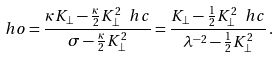Convert formula to latex. <formula><loc_0><loc_0><loc_500><loc_500>\ h o = \frac { \kappa K _ { \perp } - \frac { \kappa } { 2 } K _ { \perp } ^ { 2 } \ h c } { \sigma - \frac { \kappa } { 2 } K _ { \perp } ^ { 2 } } = \frac { K _ { \perp } - \frac { 1 } { 2 } K _ { \perp } ^ { 2 } \ h c } { \lambda ^ { - 2 } - \frac { 1 } { 2 } K _ { \perp } ^ { 2 } } \, .</formula> 